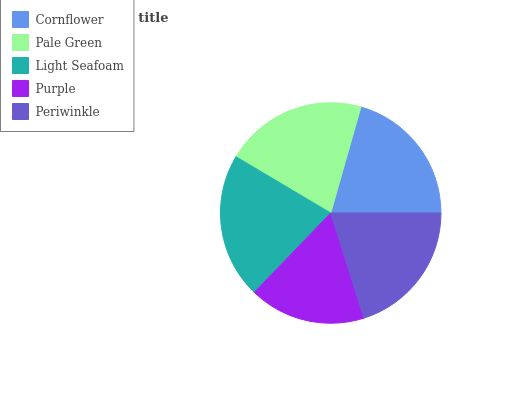Is Purple the minimum?
Answer yes or no. Yes. Is Light Seafoam the maximum?
Answer yes or no. Yes. Is Pale Green the minimum?
Answer yes or no. No. Is Pale Green the maximum?
Answer yes or no. No. Is Pale Green greater than Cornflower?
Answer yes or no. Yes. Is Cornflower less than Pale Green?
Answer yes or no. Yes. Is Cornflower greater than Pale Green?
Answer yes or no. No. Is Pale Green less than Cornflower?
Answer yes or no. No. Is Cornflower the high median?
Answer yes or no. Yes. Is Cornflower the low median?
Answer yes or no. Yes. Is Pale Green the high median?
Answer yes or no. No. Is Pale Green the low median?
Answer yes or no. No. 